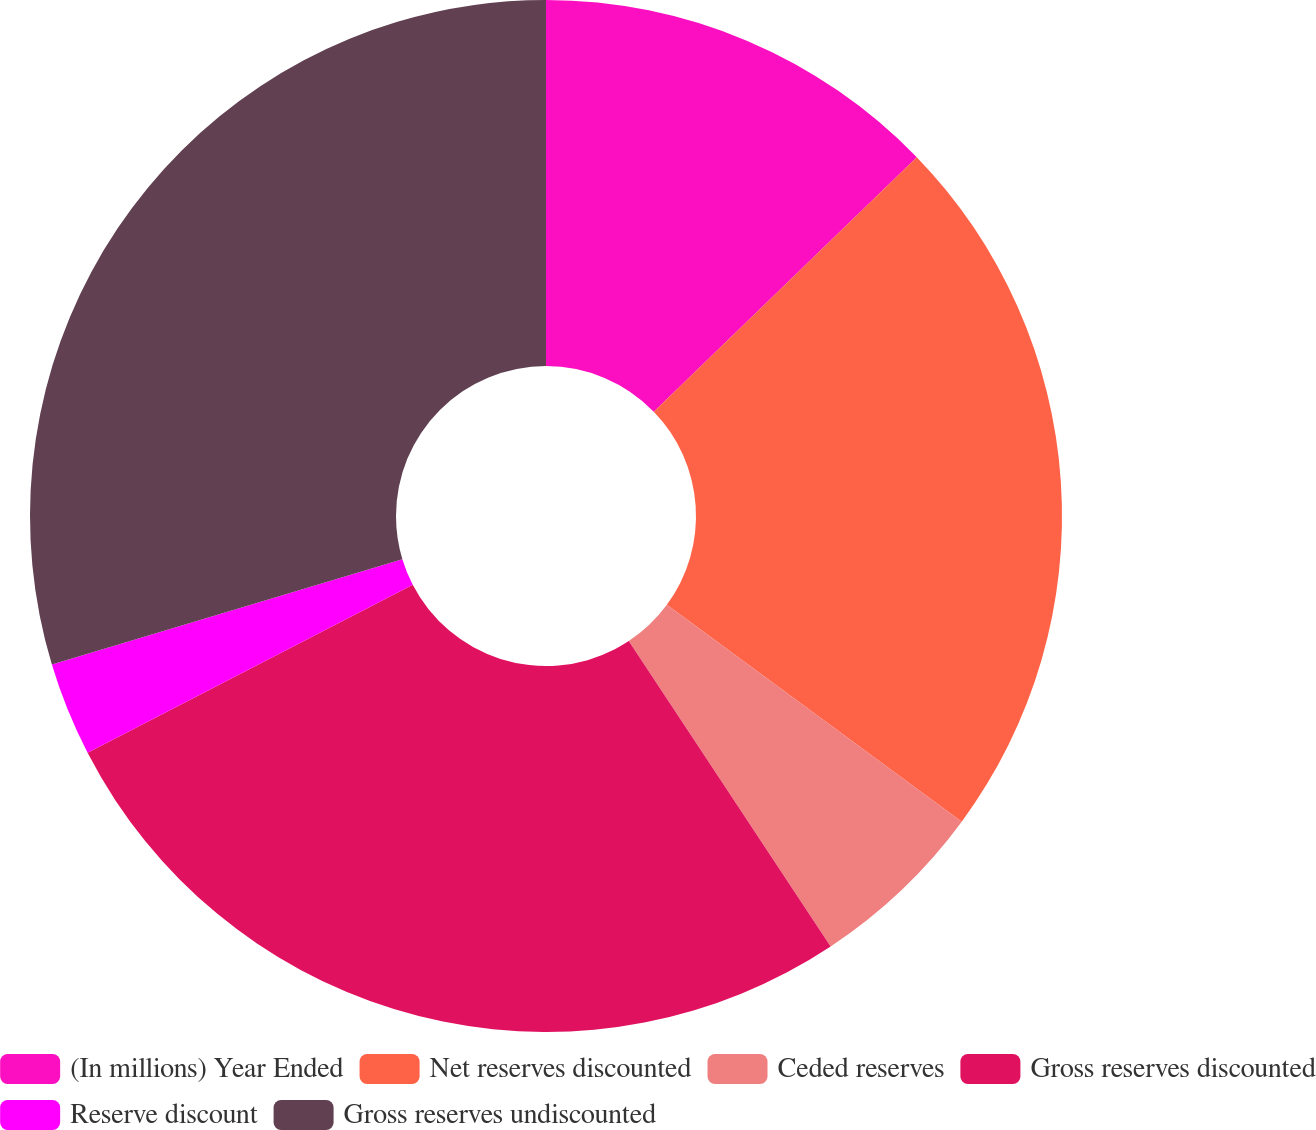Convert chart to OTSL. <chart><loc_0><loc_0><loc_500><loc_500><pie_chart><fcel>(In millions) Year Ended<fcel>Net reserves discounted<fcel>Ceded reserves<fcel>Gross reserves discounted<fcel>Reserve discount<fcel>Gross reserves undiscounted<nl><fcel>12.76%<fcel>22.33%<fcel>5.61%<fcel>26.71%<fcel>2.94%<fcel>29.65%<nl></chart> 